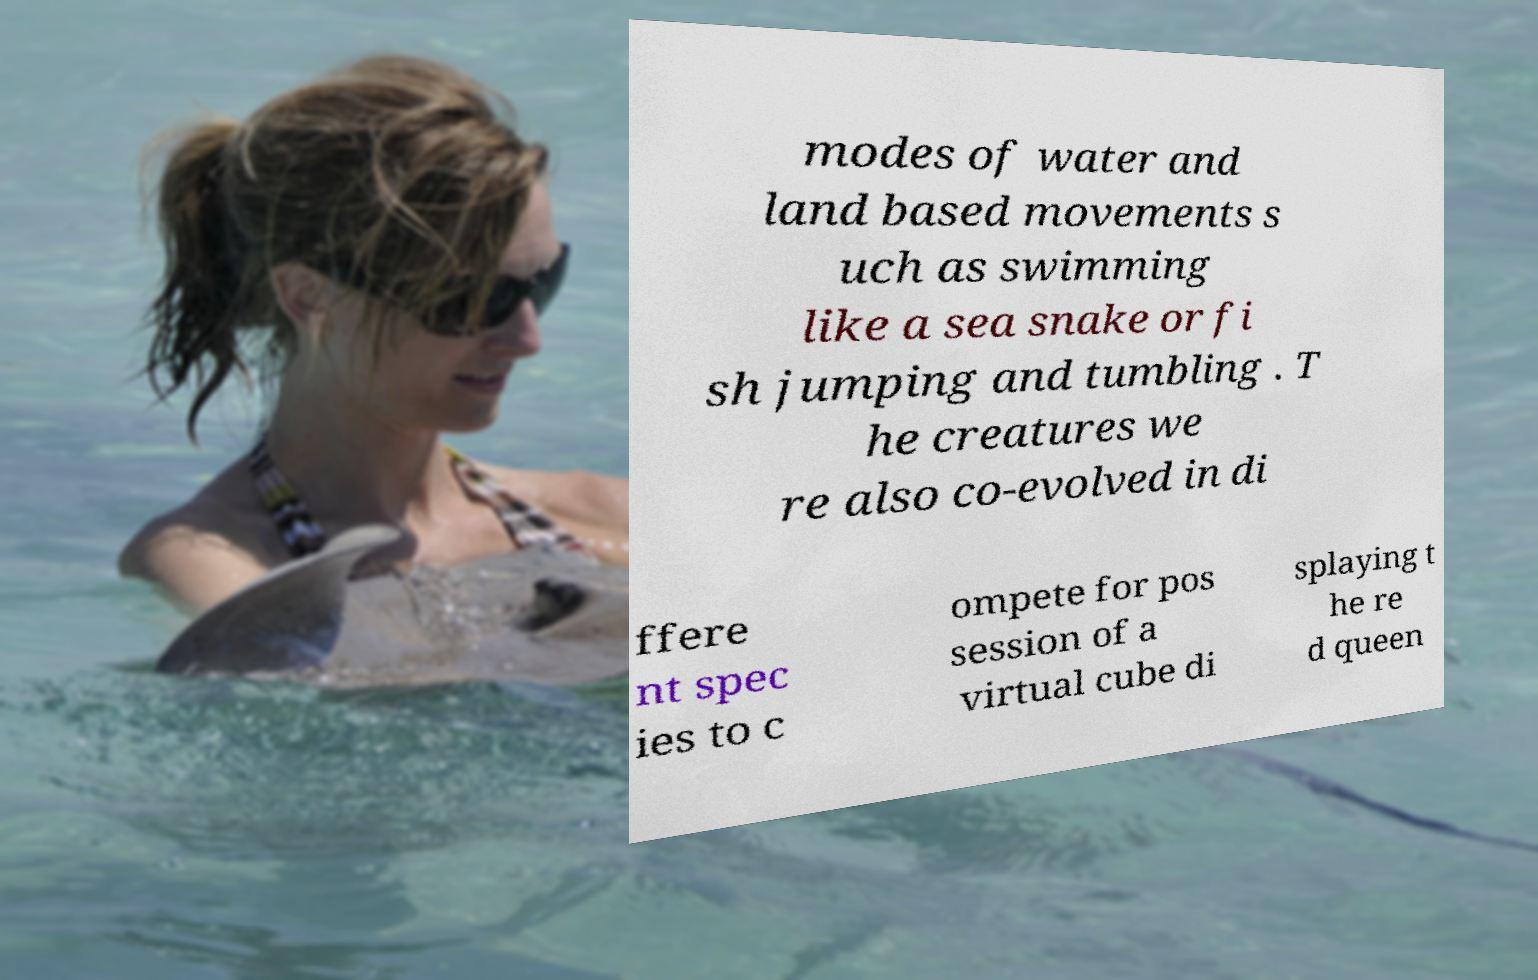Can you read and provide the text displayed in the image?This photo seems to have some interesting text. Can you extract and type it out for me? modes of water and land based movements s uch as swimming like a sea snake or fi sh jumping and tumbling . T he creatures we re also co-evolved in di ffere nt spec ies to c ompete for pos session of a virtual cube di splaying t he re d queen 